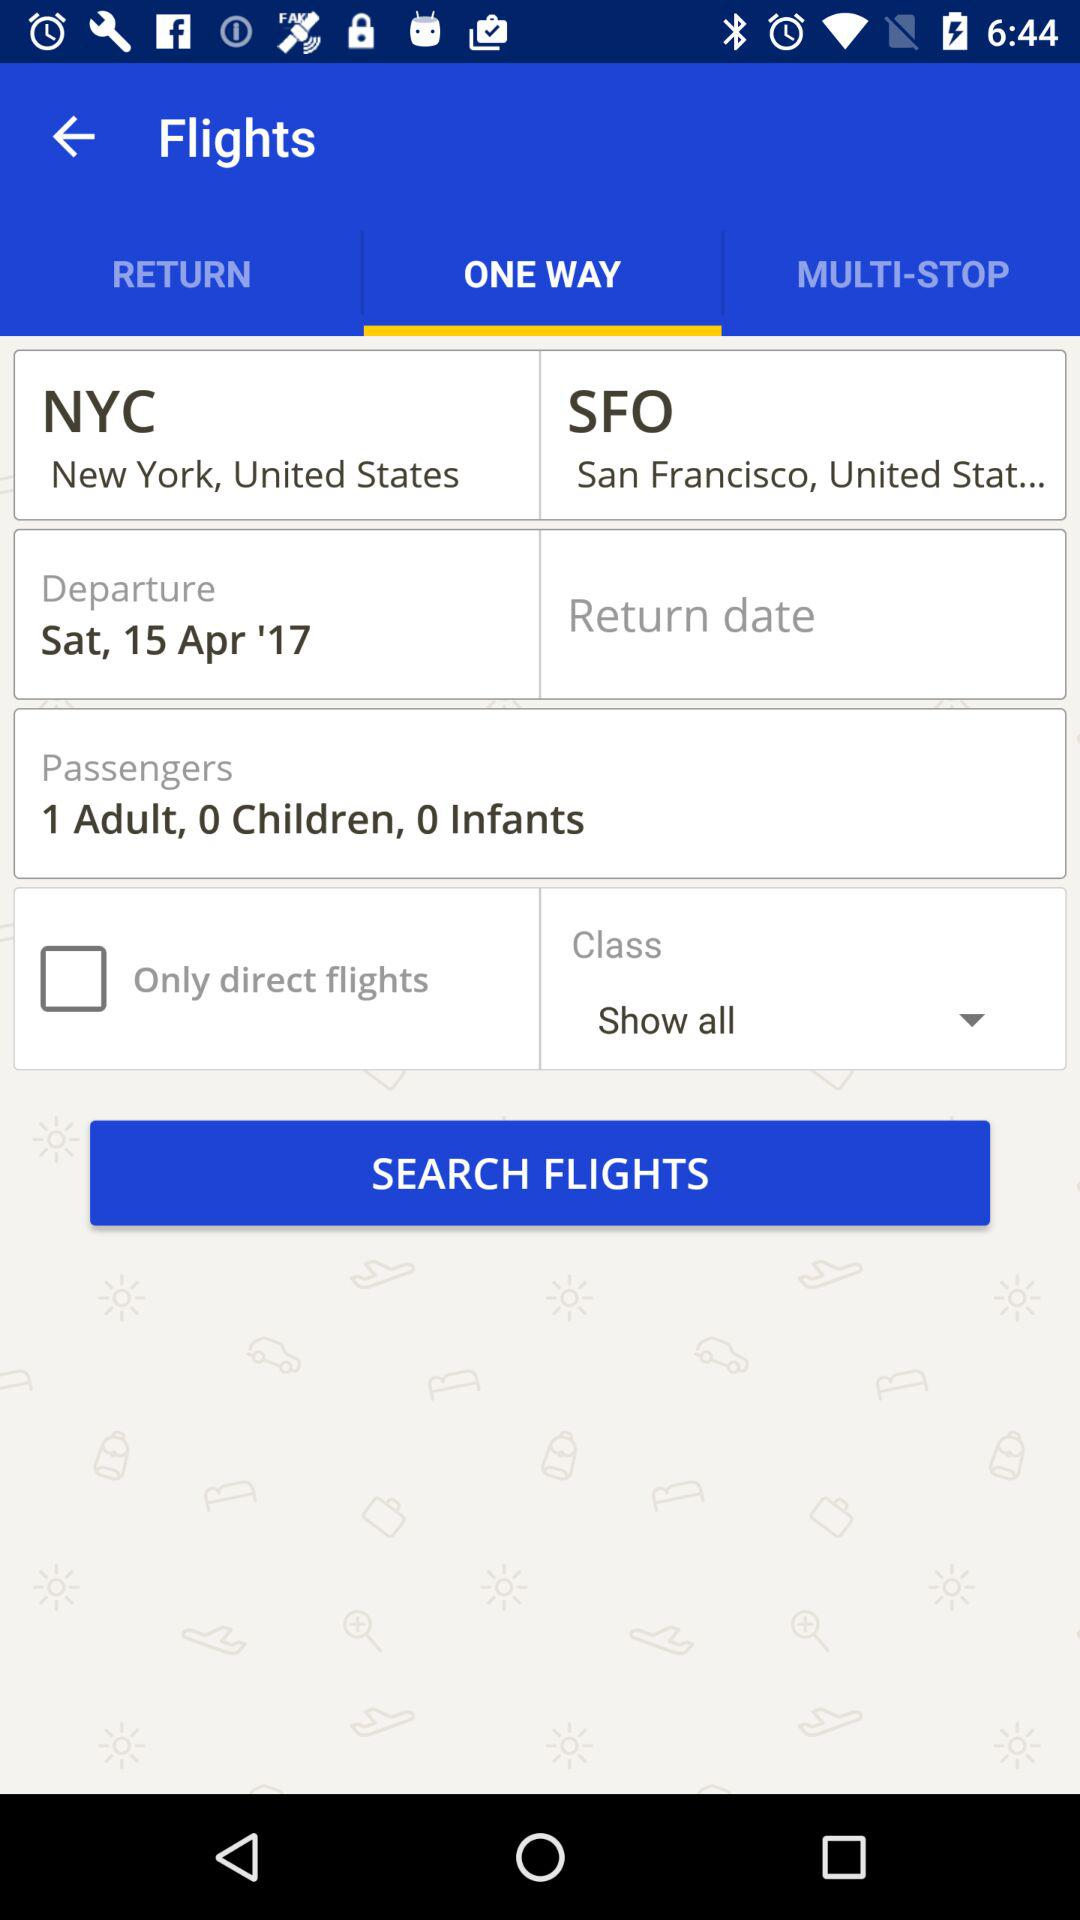How many more adults than children are in this flight search?
Answer the question using a single word or phrase. 1 